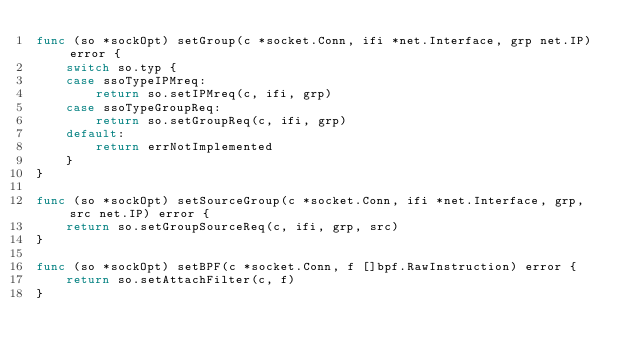Convert code to text. <code><loc_0><loc_0><loc_500><loc_500><_Go_>func (so *sockOpt) setGroup(c *socket.Conn, ifi *net.Interface, grp net.IP) error {
	switch so.typ {
	case ssoTypeIPMreq:
		return so.setIPMreq(c, ifi, grp)
	case ssoTypeGroupReq:
		return so.setGroupReq(c, ifi, grp)
	default:
		return errNotImplemented
	}
}

func (so *sockOpt) setSourceGroup(c *socket.Conn, ifi *net.Interface, grp, src net.IP) error {
	return so.setGroupSourceReq(c, ifi, grp, src)
}

func (so *sockOpt) setBPF(c *socket.Conn, f []bpf.RawInstruction) error {
	return so.setAttachFilter(c, f)
}
</code> 